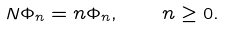Convert formula to latex. <formula><loc_0><loc_0><loc_500><loc_500>N \Phi _ { n } = n \Phi _ { n } , \quad n \geq 0 .</formula> 